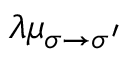Convert formula to latex. <formula><loc_0><loc_0><loc_500><loc_500>\lambda \mu _ { \sigma \to \sigma ^ { \prime } }</formula> 